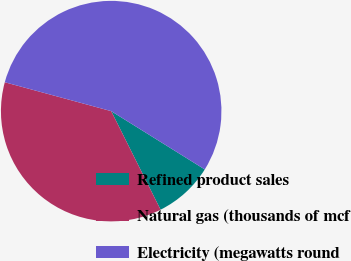<chart> <loc_0><loc_0><loc_500><loc_500><pie_chart><fcel>Refined product sales<fcel>Natural gas (thousands of mcf<fcel>Electricity (megawatts round<nl><fcel>8.74%<fcel>36.61%<fcel>54.65%<nl></chart> 